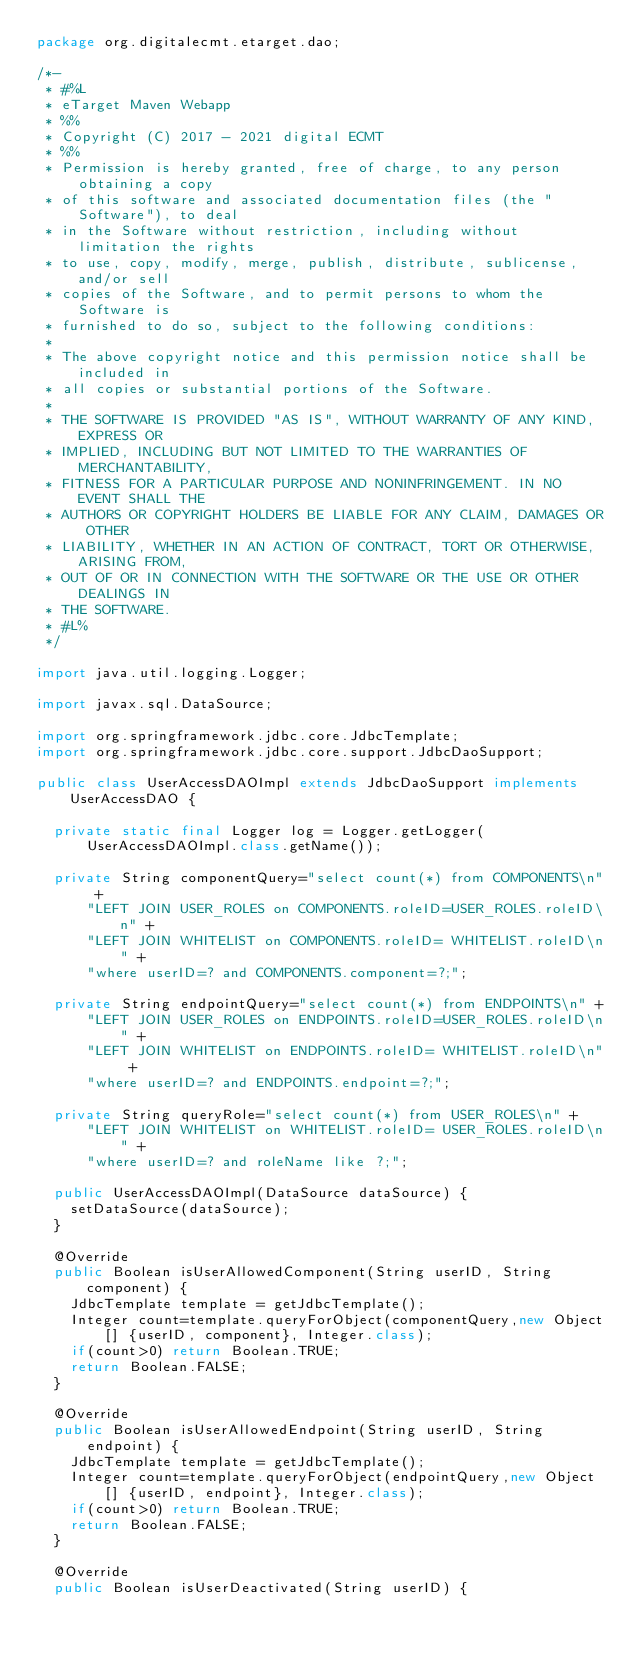Convert code to text. <code><loc_0><loc_0><loc_500><loc_500><_Java_>package org.digitalecmt.etarget.dao;

/*-
 * #%L
 * eTarget Maven Webapp
 * %%
 * Copyright (C) 2017 - 2021 digital ECMT
 * %%
 * Permission is hereby granted, free of charge, to any person obtaining a copy
 * of this software and associated documentation files (the "Software"), to deal
 * in the Software without restriction, including without limitation the rights
 * to use, copy, modify, merge, publish, distribute, sublicense, and/or sell
 * copies of the Software, and to permit persons to whom the Software is
 * furnished to do so, subject to the following conditions:
 * 
 * The above copyright notice and this permission notice shall be included in
 * all copies or substantial portions of the Software.
 * 
 * THE SOFTWARE IS PROVIDED "AS IS", WITHOUT WARRANTY OF ANY KIND, EXPRESS OR
 * IMPLIED, INCLUDING BUT NOT LIMITED TO THE WARRANTIES OF MERCHANTABILITY,
 * FITNESS FOR A PARTICULAR PURPOSE AND NONINFRINGEMENT. IN NO EVENT SHALL THE
 * AUTHORS OR COPYRIGHT HOLDERS BE LIABLE FOR ANY CLAIM, DAMAGES OR OTHER
 * LIABILITY, WHETHER IN AN ACTION OF CONTRACT, TORT OR OTHERWISE, ARISING FROM,
 * OUT OF OR IN CONNECTION WITH THE SOFTWARE OR THE USE OR OTHER DEALINGS IN
 * THE SOFTWARE.
 * #L%
 */

import java.util.logging.Logger;

import javax.sql.DataSource;

import org.springframework.jdbc.core.JdbcTemplate;
import org.springframework.jdbc.core.support.JdbcDaoSupport;

public class UserAccessDAOImpl extends JdbcDaoSupport implements UserAccessDAO {

	private static final Logger log = Logger.getLogger(UserAccessDAOImpl.class.getName());
	
	private String componentQuery="select count(*) from COMPONENTS\n" + 
			"LEFT JOIN USER_ROLES on COMPONENTS.roleID=USER_ROLES.roleID\n" + 
			"LEFT JOIN WHITELIST on COMPONENTS.roleID= WHITELIST.roleID\n" + 
			"where userID=? and COMPONENTS.component=?;";
	
	private String endpointQuery="select count(*) from ENDPOINTS\n" + 
			"LEFT JOIN USER_ROLES on ENDPOINTS.roleID=USER_ROLES.roleID\n" + 
			"LEFT JOIN WHITELIST on ENDPOINTS.roleID= WHITELIST.roleID\n" + 
			"where userID=? and ENDPOINTS.endpoint=?;";
	
	private String queryRole="select count(*) from USER_ROLES\n" + 
			"LEFT JOIN WHITELIST on WHITELIST.roleID= USER_ROLES.roleID\n" + 
			"where userID=? and roleName like ?;";
	
	public UserAccessDAOImpl(DataSource dataSource) {
		setDataSource(dataSource);
	}
	
	@Override
	public Boolean isUserAllowedComponent(String userID, String component) {
		JdbcTemplate template = getJdbcTemplate();
		Integer count=template.queryForObject(componentQuery,new Object[] {userID, component}, Integer.class);
		if(count>0) return Boolean.TRUE;
		return Boolean.FALSE;
	}

	@Override
	public Boolean isUserAllowedEndpoint(String userID, String endpoint) {
		JdbcTemplate template = getJdbcTemplate();
		Integer count=template.queryForObject(endpointQuery,new Object[] {userID, endpoint}, Integer.class);
		if(count>0) return Boolean.TRUE;
		return Boolean.FALSE;
	}

	@Override
	public Boolean isUserDeactivated(String userID) {</code> 